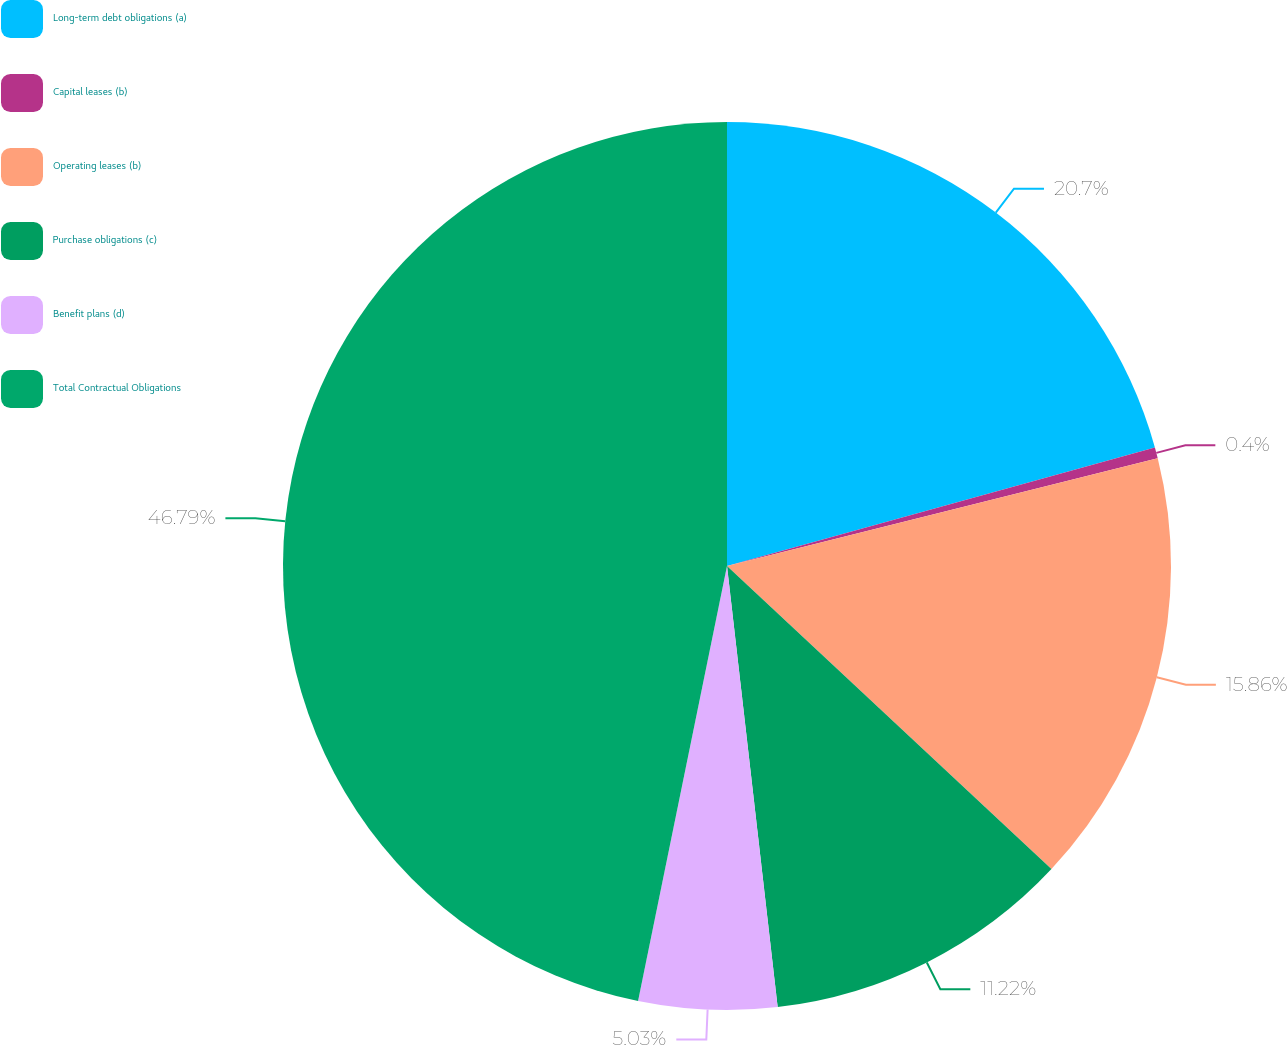Convert chart. <chart><loc_0><loc_0><loc_500><loc_500><pie_chart><fcel>Long-term debt obligations (a)<fcel>Capital leases (b)<fcel>Operating leases (b)<fcel>Purchase obligations (c)<fcel>Benefit plans (d)<fcel>Total Contractual Obligations<nl><fcel>20.7%<fcel>0.4%<fcel>15.86%<fcel>11.22%<fcel>5.03%<fcel>46.79%<nl></chart> 